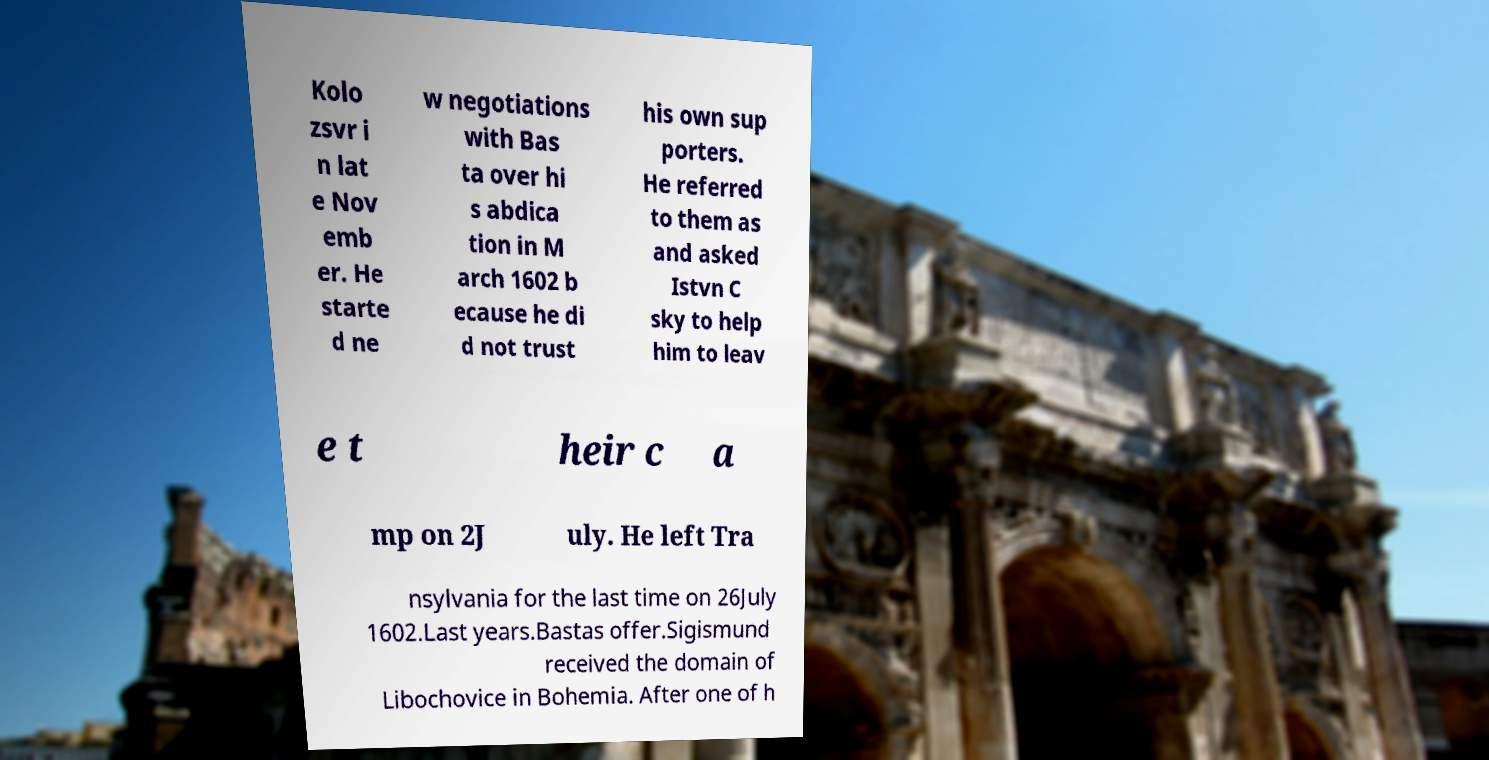Please identify and transcribe the text found in this image. Kolo zsvr i n lat e Nov emb er. He starte d ne w negotiations with Bas ta over hi s abdica tion in M arch 1602 b ecause he di d not trust his own sup porters. He referred to them as and asked Istvn C sky to help him to leav e t heir c a mp on 2J uly. He left Tra nsylvania for the last time on 26July 1602.Last years.Bastas offer.Sigismund received the domain of Libochovice in Bohemia. After one of h 